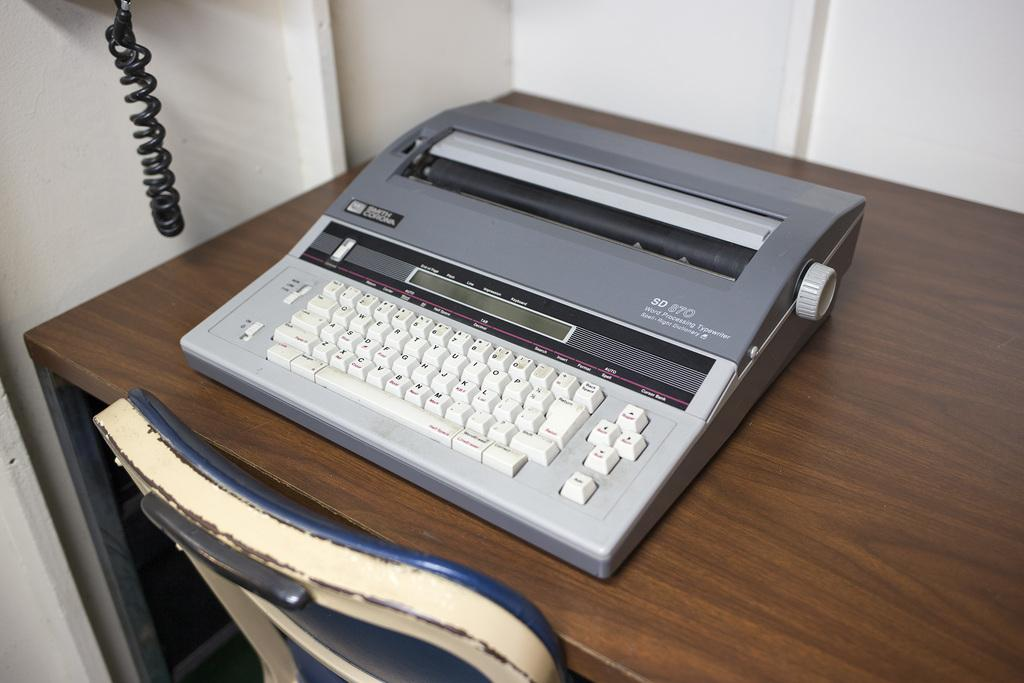<image>
Write a terse but informative summary of the picture. a typewriter with white keys that says SD 870 on it 